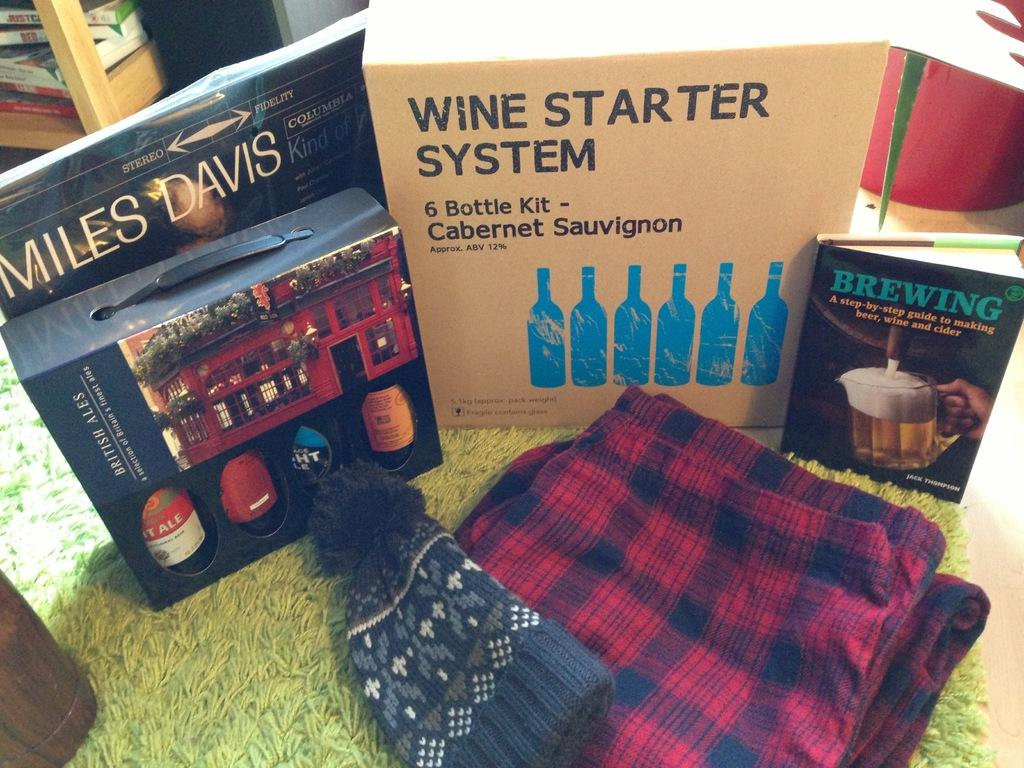Provide a one-sentence caption for the provided image. Wine Starter System book next to a Brewing book as well. 